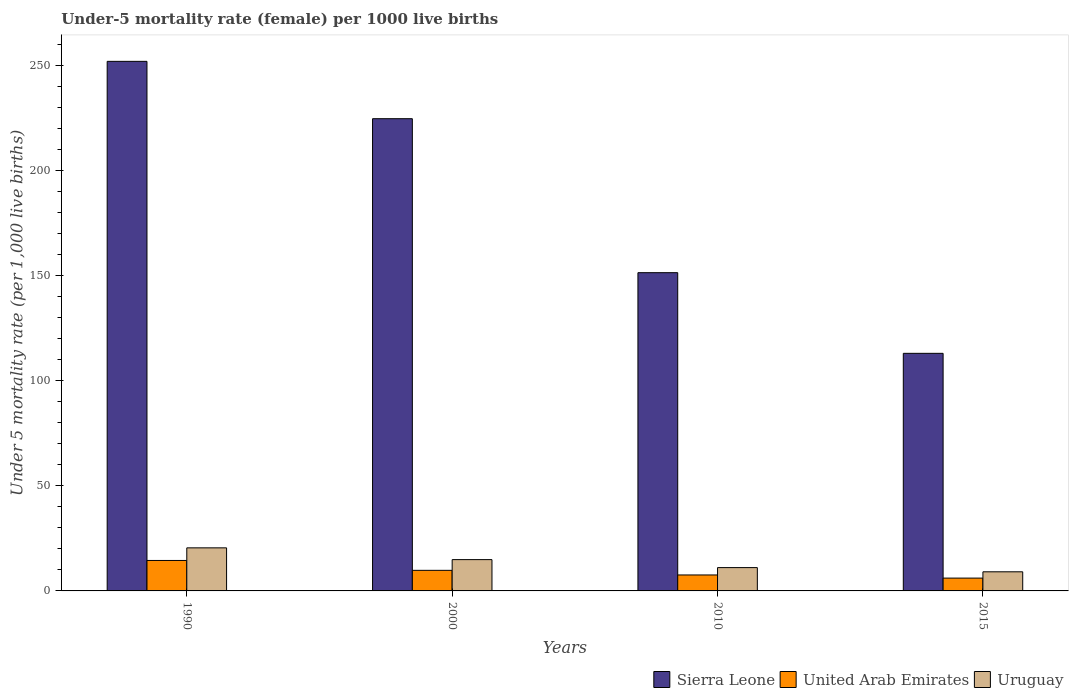How many groups of bars are there?
Provide a short and direct response. 4. Are the number of bars on each tick of the X-axis equal?
Offer a very short reply. Yes. How many bars are there on the 1st tick from the left?
Offer a terse response. 3. How many bars are there on the 1st tick from the right?
Provide a short and direct response. 3. What is the label of the 4th group of bars from the left?
Ensure brevity in your answer.  2015. What is the under-five mortality rate in Sierra Leone in 2000?
Ensure brevity in your answer.  224.8. Across all years, what is the maximum under-five mortality rate in Sierra Leone?
Keep it short and to the point. 252.1. Across all years, what is the minimum under-five mortality rate in Sierra Leone?
Offer a very short reply. 113.1. In which year was the under-five mortality rate in Uruguay maximum?
Provide a succinct answer. 1990. In which year was the under-five mortality rate in Uruguay minimum?
Your answer should be compact. 2015. What is the total under-five mortality rate in Sierra Leone in the graph?
Keep it short and to the point. 741.5. What is the difference between the under-five mortality rate in Sierra Leone in 2000 and that in 2010?
Provide a succinct answer. 73.3. What is the difference between the under-five mortality rate in Uruguay in 2000 and the under-five mortality rate in United Arab Emirates in 2010?
Provide a short and direct response. 7.3. In the year 1990, what is the difference between the under-five mortality rate in United Arab Emirates and under-five mortality rate in Sierra Leone?
Make the answer very short. -237.6. What is the ratio of the under-five mortality rate in United Arab Emirates in 1990 to that in 2000?
Offer a very short reply. 1.48. Is the under-five mortality rate in Sierra Leone in 1990 less than that in 2015?
Your answer should be very brief. No. Is the difference between the under-five mortality rate in United Arab Emirates in 1990 and 2000 greater than the difference between the under-five mortality rate in Sierra Leone in 1990 and 2000?
Your answer should be compact. No. What is the difference between the highest and the second highest under-five mortality rate in United Arab Emirates?
Give a very brief answer. 4.7. Is the sum of the under-five mortality rate in United Arab Emirates in 2000 and 2010 greater than the maximum under-five mortality rate in Sierra Leone across all years?
Provide a succinct answer. No. What does the 1st bar from the left in 1990 represents?
Your answer should be very brief. Sierra Leone. What does the 1st bar from the right in 2010 represents?
Your answer should be compact. Uruguay. Are all the bars in the graph horizontal?
Offer a terse response. No. How many years are there in the graph?
Your answer should be very brief. 4. Are the values on the major ticks of Y-axis written in scientific E-notation?
Keep it short and to the point. No. Does the graph contain any zero values?
Provide a short and direct response. No. How are the legend labels stacked?
Ensure brevity in your answer.  Horizontal. What is the title of the graph?
Your answer should be compact. Under-5 mortality rate (female) per 1000 live births. Does "OECD members" appear as one of the legend labels in the graph?
Your answer should be compact. No. What is the label or title of the Y-axis?
Provide a short and direct response. Under 5 mortality rate (per 1,0 live births). What is the Under 5 mortality rate (per 1,000 live births) in Sierra Leone in 1990?
Your answer should be compact. 252.1. What is the Under 5 mortality rate (per 1,000 live births) of United Arab Emirates in 1990?
Provide a succinct answer. 14.5. What is the Under 5 mortality rate (per 1,000 live births) of Uruguay in 1990?
Keep it short and to the point. 20.5. What is the Under 5 mortality rate (per 1,000 live births) of Sierra Leone in 2000?
Make the answer very short. 224.8. What is the Under 5 mortality rate (per 1,000 live births) of United Arab Emirates in 2000?
Your response must be concise. 9.8. What is the Under 5 mortality rate (per 1,000 live births) of Sierra Leone in 2010?
Keep it short and to the point. 151.5. What is the Under 5 mortality rate (per 1,000 live births) in United Arab Emirates in 2010?
Offer a very short reply. 7.6. What is the Under 5 mortality rate (per 1,000 live births) in Uruguay in 2010?
Provide a short and direct response. 11.1. What is the Under 5 mortality rate (per 1,000 live births) in Sierra Leone in 2015?
Offer a terse response. 113.1. What is the Under 5 mortality rate (per 1,000 live births) in United Arab Emirates in 2015?
Make the answer very short. 6.1. Across all years, what is the maximum Under 5 mortality rate (per 1,000 live births) in Sierra Leone?
Offer a terse response. 252.1. Across all years, what is the minimum Under 5 mortality rate (per 1,000 live births) in Sierra Leone?
Make the answer very short. 113.1. What is the total Under 5 mortality rate (per 1,000 live births) in Sierra Leone in the graph?
Provide a succinct answer. 741.5. What is the total Under 5 mortality rate (per 1,000 live births) of Uruguay in the graph?
Give a very brief answer. 55.6. What is the difference between the Under 5 mortality rate (per 1,000 live births) of Sierra Leone in 1990 and that in 2000?
Offer a very short reply. 27.3. What is the difference between the Under 5 mortality rate (per 1,000 live births) of Sierra Leone in 1990 and that in 2010?
Your answer should be very brief. 100.6. What is the difference between the Under 5 mortality rate (per 1,000 live births) of United Arab Emirates in 1990 and that in 2010?
Provide a short and direct response. 6.9. What is the difference between the Under 5 mortality rate (per 1,000 live births) in Uruguay in 1990 and that in 2010?
Provide a short and direct response. 9.4. What is the difference between the Under 5 mortality rate (per 1,000 live births) of Sierra Leone in 1990 and that in 2015?
Your response must be concise. 139. What is the difference between the Under 5 mortality rate (per 1,000 live births) of United Arab Emirates in 1990 and that in 2015?
Offer a very short reply. 8.4. What is the difference between the Under 5 mortality rate (per 1,000 live births) of Uruguay in 1990 and that in 2015?
Offer a very short reply. 11.4. What is the difference between the Under 5 mortality rate (per 1,000 live births) in Sierra Leone in 2000 and that in 2010?
Your answer should be very brief. 73.3. What is the difference between the Under 5 mortality rate (per 1,000 live births) in United Arab Emirates in 2000 and that in 2010?
Your answer should be compact. 2.2. What is the difference between the Under 5 mortality rate (per 1,000 live births) of Uruguay in 2000 and that in 2010?
Keep it short and to the point. 3.8. What is the difference between the Under 5 mortality rate (per 1,000 live births) of Sierra Leone in 2000 and that in 2015?
Keep it short and to the point. 111.7. What is the difference between the Under 5 mortality rate (per 1,000 live births) of United Arab Emirates in 2000 and that in 2015?
Your response must be concise. 3.7. What is the difference between the Under 5 mortality rate (per 1,000 live births) of Sierra Leone in 2010 and that in 2015?
Provide a short and direct response. 38.4. What is the difference between the Under 5 mortality rate (per 1,000 live births) of Uruguay in 2010 and that in 2015?
Give a very brief answer. 2. What is the difference between the Under 5 mortality rate (per 1,000 live births) of Sierra Leone in 1990 and the Under 5 mortality rate (per 1,000 live births) of United Arab Emirates in 2000?
Keep it short and to the point. 242.3. What is the difference between the Under 5 mortality rate (per 1,000 live births) of Sierra Leone in 1990 and the Under 5 mortality rate (per 1,000 live births) of Uruguay in 2000?
Provide a short and direct response. 237.2. What is the difference between the Under 5 mortality rate (per 1,000 live births) in Sierra Leone in 1990 and the Under 5 mortality rate (per 1,000 live births) in United Arab Emirates in 2010?
Your answer should be very brief. 244.5. What is the difference between the Under 5 mortality rate (per 1,000 live births) in Sierra Leone in 1990 and the Under 5 mortality rate (per 1,000 live births) in Uruguay in 2010?
Provide a short and direct response. 241. What is the difference between the Under 5 mortality rate (per 1,000 live births) in Sierra Leone in 1990 and the Under 5 mortality rate (per 1,000 live births) in United Arab Emirates in 2015?
Your answer should be compact. 246. What is the difference between the Under 5 mortality rate (per 1,000 live births) of Sierra Leone in 1990 and the Under 5 mortality rate (per 1,000 live births) of Uruguay in 2015?
Offer a terse response. 243. What is the difference between the Under 5 mortality rate (per 1,000 live births) in Sierra Leone in 2000 and the Under 5 mortality rate (per 1,000 live births) in United Arab Emirates in 2010?
Offer a very short reply. 217.2. What is the difference between the Under 5 mortality rate (per 1,000 live births) in Sierra Leone in 2000 and the Under 5 mortality rate (per 1,000 live births) in Uruguay in 2010?
Provide a succinct answer. 213.7. What is the difference between the Under 5 mortality rate (per 1,000 live births) of United Arab Emirates in 2000 and the Under 5 mortality rate (per 1,000 live births) of Uruguay in 2010?
Your answer should be very brief. -1.3. What is the difference between the Under 5 mortality rate (per 1,000 live births) of Sierra Leone in 2000 and the Under 5 mortality rate (per 1,000 live births) of United Arab Emirates in 2015?
Your answer should be compact. 218.7. What is the difference between the Under 5 mortality rate (per 1,000 live births) in Sierra Leone in 2000 and the Under 5 mortality rate (per 1,000 live births) in Uruguay in 2015?
Your answer should be very brief. 215.7. What is the difference between the Under 5 mortality rate (per 1,000 live births) in United Arab Emirates in 2000 and the Under 5 mortality rate (per 1,000 live births) in Uruguay in 2015?
Your answer should be compact. 0.7. What is the difference between the Under 5 mortality rate (per 1,000 live births) in Sierra Leone in 2010 and the Under 5 mortality rate (per 1,000 live births) in United Arab Emirates in 2015?
Give a very brief answer. 145.4. What is the difference between the Under 5 mortality rate (per 1,000 live births) of Sierra Leone in 2010 and the Under 5 mortality rate (per 1,000 live births) of Uruguay in 2015?
Give a very brief answer. 142.4. What is the difference between the Under 5 mortality rate (per 1,000 live births) in United Arab Emirates in 2010 and the Under 5 mortality rate (per 1,000 live births) in Uruguay in 2015?
Ensure brevity in your answer.  -1.5. What is the average Under 5 mortality rate (per 1,000 live births) of Sierra Leone per year?
Your answer should be compact. 185.38. What is the average Under 5 mortality rate (per 1,000 live births) of Uruguay per year?
Make the answer very short. 13.9. In the year 1990, what is the difference between the Under 5 mortality rate (per 1,000 live births) in Sierra Leone and Under 5 mortality rate (per 1,000 live births) in United Arab Emirates?
Keep it short and to the point. 237.6. In the year 1990, what is the difference between the Under 5 mortality rate (per 1,000 live births) of Sierra Leone and Under 5 mortality rate (per 1,000 live births) of Uruguay?
Your answer should be compact. 231.6. In the year 1990, what is the difference between the Under 5 mortality rate (per 1,000 live births) in United Arab Emirates and Under 5 mortality rate (per 1,000 live births) in Uruguay?
Give a very brief answer. -6. In the year 2000, what is the difference between the Under 5 mortality rate (per 1,000 live births) of Sierra Leone and Under 5 mortality rate (per 1,000 live births) of United Arab Emirates?
Make the answer very short. 215. In the year 2000, what is the difference between the Under 5 mortality rate (per 1,000 live births) in Sierra Leone and Under 5 mortality rate (per 1,000 live births) in Uruguay?
Provide a succinct answer. 209.9. In the year 2000, what is the difference between the Under 5 mortality rate (per 1,000 live births) of United Arab Emirates and Under 5 mortality rate (per 1,000 live births) of Uruguay?
Ensure brevity in your answer.  -5.1. In the year 2010, what is the difference between the Under 5 mortality rate (per 1,000 live births) of Sierra Leone and Under 5 mortality rate (per 1,000 live births) of United Arab Emirates?
Provide a short and direct response. 143.9. In the year 2010, what is the difference between the Under 5 mortality rate (per 1,000 live births) of Sierra Leone and Under 5 mortality rate (per 1,000 live births) of Uruguay?
Your response must be concise. 140.4. In the year 2010, what is the difference between the Under 5 mortality rate (per 1,000 live births) in United Arab Emirates and Under 5 mortality rate (per 1,000 live births) in Uruguay?
Your answer should be very brief. -3.5. In the year 2015, what is the difference between the Under 5 mortality rate (per 1,000 live births) of Sierra Leone and Under 5 mortality rate (per 1,000 live births) of United Arab Emirates?
Provide a short and direct response. 107. In the year 2015, what is the difference between the Under 5 mortality rate (per 1,000 live births) in Sierra Leone and Under 5 mortality rate (per 1,000 live births) in Uruguay?
Ensure brevity in your answer.  104. In the year 2015, what is the difference between the Under 5 mortality rate (per 1,000 live births) of United Arab Emirates and Under 5 mortality rate (per 1,000 live births) of Uruguay?
Keep it short and to the point. -3. What is the ratio of the Under 5 mortality rate (per 1,000 live births) in Sierra Leone in 1990 to that in 2000?
Provide a short and direct response. 1.12. What is the ratio of the Under 5 mortality rate (per 1,000 live births) in United Arab Emirates in 1990 to that in 2000?
Your answer should be compact. 1.48. What is the ratio of the Under 5 mortality rate (per 1,000 live births) in Uruguay in 1990 to that in 2000?
Ensure brevity in your answer.  1.38. What is the ratio of the Under 5 mortality rate (per 1,000 live births) in Sierra Leone in 1990 to that in 2010?
Provide a succinct answer. 1.66. What is the ratio of the Under 5 mortality rate (per 1,000 live births) of United Arab Emirates in 1990 to that in 2010?
Your answer should be very brief. 1.91. What is the ratio of the Under 5 mortality rate (per 1,000 live births) of Uruguay in 1990 to that in 2010?
Provide a succinct answer. 1.85. What is the ratio of the Under 5 mortality rate (per 1,000 live births) in Sierra Leone in 1990 to that in 2015?
Your answer should be compact. 2.23. What is the ratio of the Under 5 mortality rate (per 1,000 live births) of United Arab Emirates in 1990 to that in 2015?
Make the answer very short. 2.38. What is the ratio of the Under 5 mortality rate (per 1,000 live births) of Uruguay in 1990 to that in 2015?
Ensure brevity in your answer.  2.25. What is the ratio of the Under 5 mortality rate (per 1,000 live births) of Sierra Leone in 2000 to that in 2010?
Ensure brevity in your answer.  1.48. What is the ratio of the Under 5 mortality rate (per 1,000 live births) of United Arab Emirates in 2000 to that in 2010?
Provide a short and direct response. 1.29. What is the ratio of the Under 5 mortality rate (per 1,000 live births) in Uruguay in 2000 to that in 2010?
Ensure brevity in your answer.  1.34. What is the ratio of the Under 5 mortality rate (per 1,000 live births) of Sierra Leone in 2000 to that in 2015?
Your answer should be very brief. 1.99. What is the ratio of the Under 5 mortality rate (per 1,000 live births) in United Arab Emirates in 2000 to that in 2015?
Make the answer very short. 1.61. What is the ratio of the Under 5 mortality rate (per 1,000 live births) in Uruguay in 2000 to that in 2015?
Ensure brevity in your answer.  1.64. What is the ratio of the Under 5 mortality rate (per 1,000 live births) of Sierra Leone in 2010 to that in 2015?
Offer a terse response. 1.34. What is the ratio of the Under 5 mortality rate (per 1,000 live births) in United Arab Emirates in 2010 to that in 2015?
Your answer should be very brief. 1.25. What is the ratio of the Under 5 mortality rate (per 1,000 live births) in Uruguay in 2010 to that in 2015?
Ensure brevity in your answer.  1.22. What is the difference between the highest and the second highest Under 5 mortality rate (per 1,000 live births) in Sierra Leone?
Your response must be concise. 27.3. What is the difference between the highest and the second highest Under 5 mortality rate (per 1,000 live births) of Uruguay?
Your answer should be very brief. 5.6. What is the difference between the highest and the lowest Under 5 mortality rate (per 1,000 live births) in Sierra Leone?
Ensure brevity in your answer.  139. 